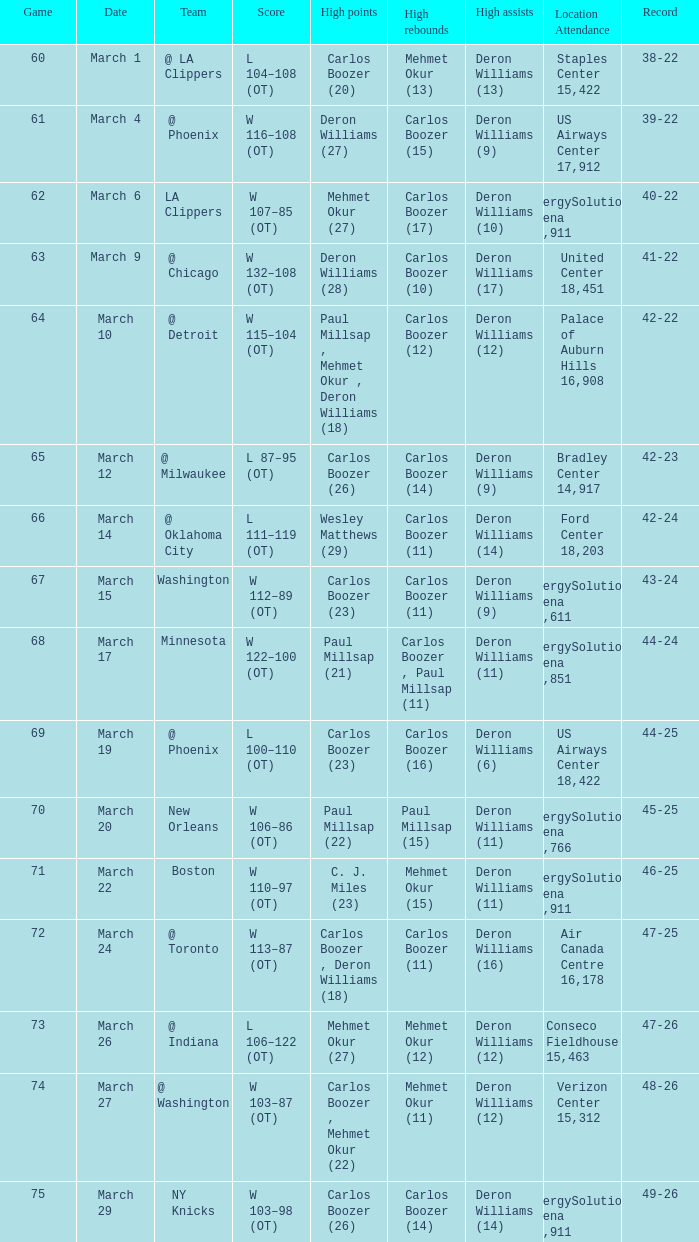What was the result at the game where deron williams (6) achieved the most assists? 44-25. Can you give me this table as a dict? {'header': ['Game', 'Date', 'Team', 'Score', 'High points', 'High rebounds', 'High assists', 'Location Attendance', 'Record'], 'rows': [['60', 'March 1', '@ LA Clippers', 'L 104–108 (OT)', 'Carlos Boozer (20)', 'Mehmet Okur (13)', 'Deron Williams (13)', 'Staples Center 15,422', '38-22'], ['61', 'March 4', '@ Phoenix', 'W 116–108 (OT)', 'Deron Williams (27)', 'Carlos Boozer (15)', 'Deron Williams (9)', 'US Airways Center 17,912', '39-22'], ['62', 'March 6', 'LA Clippers', 'W 107–85 (OT)', 'Mehmet Okur (27)', 'Carlos Boozer (17)', 'Deron Williams (10)', 'EnergySolutions Arena 19,911', '40-22'], ['63', 'March 9', '@ Chicago', 'W 132–108 (OT)', 'Deron Williams (28)', 'Carlos Boozer (10)', 'Deron Williams (17)', 'United Center 18,451', '41-22'], ['64', 'March 10', '@ Detroit', 'W 115–104 (OT)', 'Paul Millsap , Mehmet Okur , Deron Williams (18)', 'Carlos Boozer (12)', 'Deron Williams (12)', 'Palace of Auburn Hills 16,908', '42-22'], ['65', 'March 12', '@ Milwaukee', 'L 87–95 (OT)', 'Carlos Boozer (26)', 'Carlos Boozer (14)', 'Deron Williams (9)', 'Bradley Center 14,917', '42-23'], ['66', 'March 14', '@ Oklahoma City', 'L 111–119 (OT)', 'Wesley Matthews (29)', 'Carlos Boozer (11)', 'Deron Williams (14)', 'Ford Center 18,203', '42-24'], ['67', 'March 15', 'Washington', 'W 112–89 (OT)', 'Carlos Boozer (23)', 'Carlos Boozer (11)', 'Deron Williams (9)', 'EnergySolutions Arena 19,611', '43-24'], ['68', 'March 17', 'Minnesota', 'W 122–100 (OT)', 'Paul Millsap (21)', 'Carlos Boozer , Paul Millsap (11)', 'Deron Williams (11)', 'EnergySolutions Arena 19,851', '44-24'], ['69', 'March 19', '@ Phoenix', 'L 100–110 (OT)', 'Carlos Boozer (23)', 'Carlos Boozer (16)', 'Deron Williams (6)', 'US Airways Center 18,422', '44-25'], ['70', 'March 20', 'New Orleans', 'W 106–86 (OT)', 'Paul Millsap (22)', 'Paul Millsap (15)', 'Deron Williams (11)', 'EnergySolutions Arena 18,766', '45-25'], ['71', 'March 22', 'Boston', 'W 110–97 (OT)', 'C. J. Miles (23)', 'Mehmet Okur (15)', 'Deron Williams (11)', 'EnergySolutions Arena 19,911', '46-25'], ['72', 'March 24', '@ Toronto', 'W 113–87 (OT)', 'Carlos Boozer , Deron Williams (18)', 'Carlos Boozer (11)', 'Deron Williams (16)', 'Air Canada Centre 16,178', '47-25'], ['73', 'March 26', '@ Indiana', 'L 106–122 (OT)', 'Mehmet Okur (27)', 'Mehmet Okur (12)', 'Deron Williams (12)', 'Conseco Fieldhouse 15,463', '47-26'], ['74', 'March 27', '@ Washington', 'W 103–87 (OT)', 'Carlos Boozer , Mehmet Okur (22)', 'Mehmet Okur (11)', 'Deron Williams (12)', 'Verizon Center 15,312', '48-26'], ['75', 'March 29', 'NY Knicks', 'W 103–98 (OT)', 'Carlos Boozer (26)', 'Carlos Boozer (14)', 'Deron Williams (14)', 'EnergySolutions Arena 19,911', '49-26']]} 